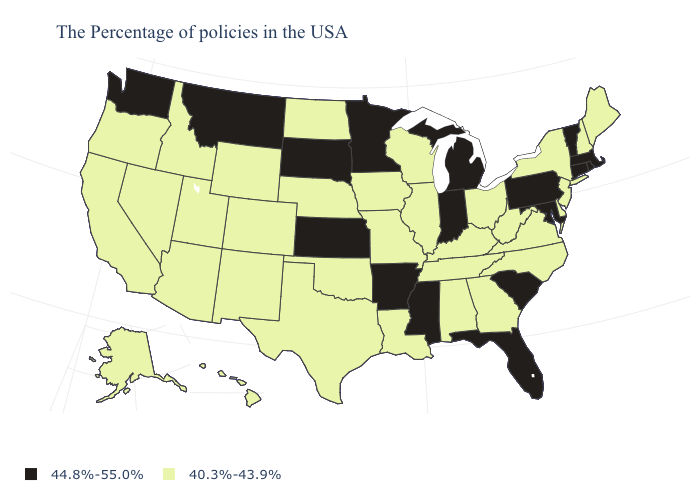Name the states that have a value in the range 40.3%-43.9%?
Write a very short answer. Maine, New Hampshire, New York, New Jersey, Delaware, Virginia, North Carolina, West Virginia, Ohio, Georgia, Kentucky, Alabama, Tennessee, Wisconsin, Illinois, Louisiana, Missouri, Iowa, Nebraska, Oklahoma, Texas, North Dakota, Wyoming, Colorado, New Mexico, Utah, Arizona, Idaho, Nevada, California, Oregon, Alaska, Hawaii. What is the value of Tennessee?
Short answer required. 40.3%-43.9%. Does Nebraska have the lowest value in the MidWest?
Quick response, please. Yes. Name the states that have a value in the range 44.8%-55.0%?
Quick response, please. Massachusetts, Rhode Island, Vermont, Connecticut, Maryland, Pennsylvania, South Carolina, Florida, Michigan, Indiana, Mississippi, Arkansas, Minnesota, Kansas, South Dakota, Montana, Washington. Among the states that border New York , which have the lowest value?
Be succinct. New Jersey. What is the value of Vermont?
Write a very short answer. 44.8%-55.0%. What is the value of Arizona?
Give a very brief answer. 40.3%-43.9%. What is the lowest value in the MidWest?
Concise answer only. 40.3%-43.9%. What is the lowest value in the USA?
Quick response, please. 40.3%-43.9%. What is the highest value in the USA?
Quick response, please. 44.8%-55.0%. Name the states that have a value in the range 40.3%-43.9%?
Short answer required. Maine, New Hampshire, New York, New Jersey, Delaware, Virginia, North Carolina, West Virginia, Ohio, Georgia, Kentucky, Alabama, Tennessee, Wisconsin, Illinois, Louisiana, Missouri, Iowa, Nebraska, Oklahoma, Texas, North Dakota, Wyoming, Colorado, New Mexico, Utah, Arizona, Idaho, Nevada, California, Oregon, Alaska, Hawaii. What is the value of Tennessee?
Be succinct. 40.3%-43.9%. Among the states that border West Virginia , does Pennsylvania have the lowest value?
Give a very brief answer. No. 